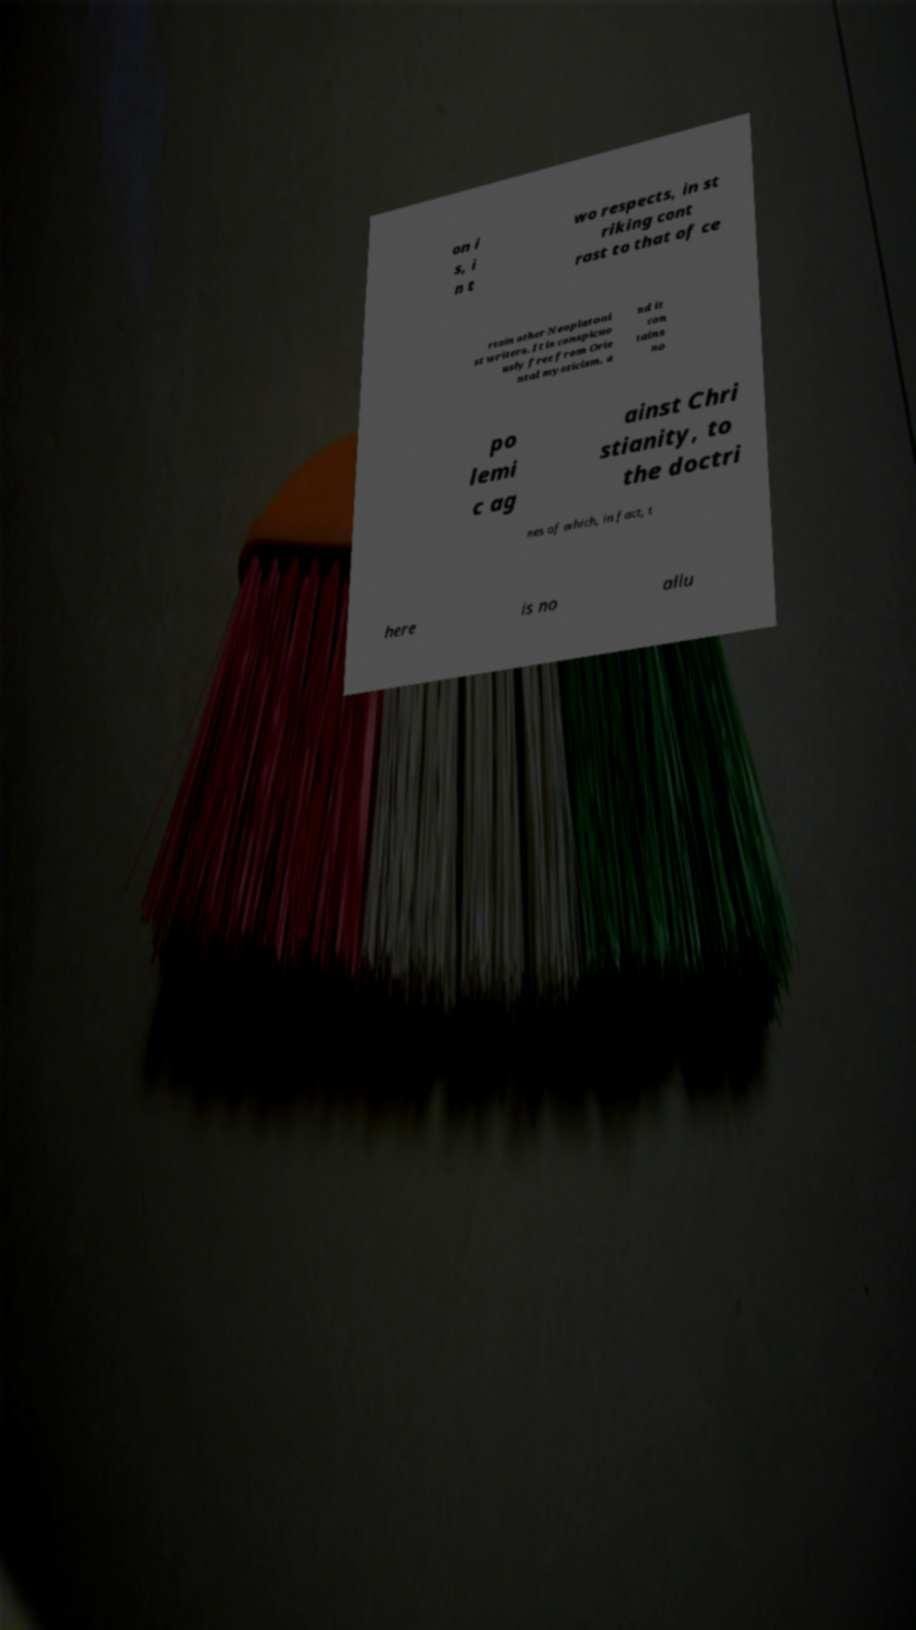Could you assist in decoding the text presented in this image and type it out clearly? on i s, i n t wo respects, in st riking cont rast to that of ce rtain other Neoplatoni st writers. It is conspicuo usly free from Orie ntal mysticism, a nd it con tains no po lemi c ag ainst Chri stianity, to the doctri nes of which, in fact, t here is no allu 